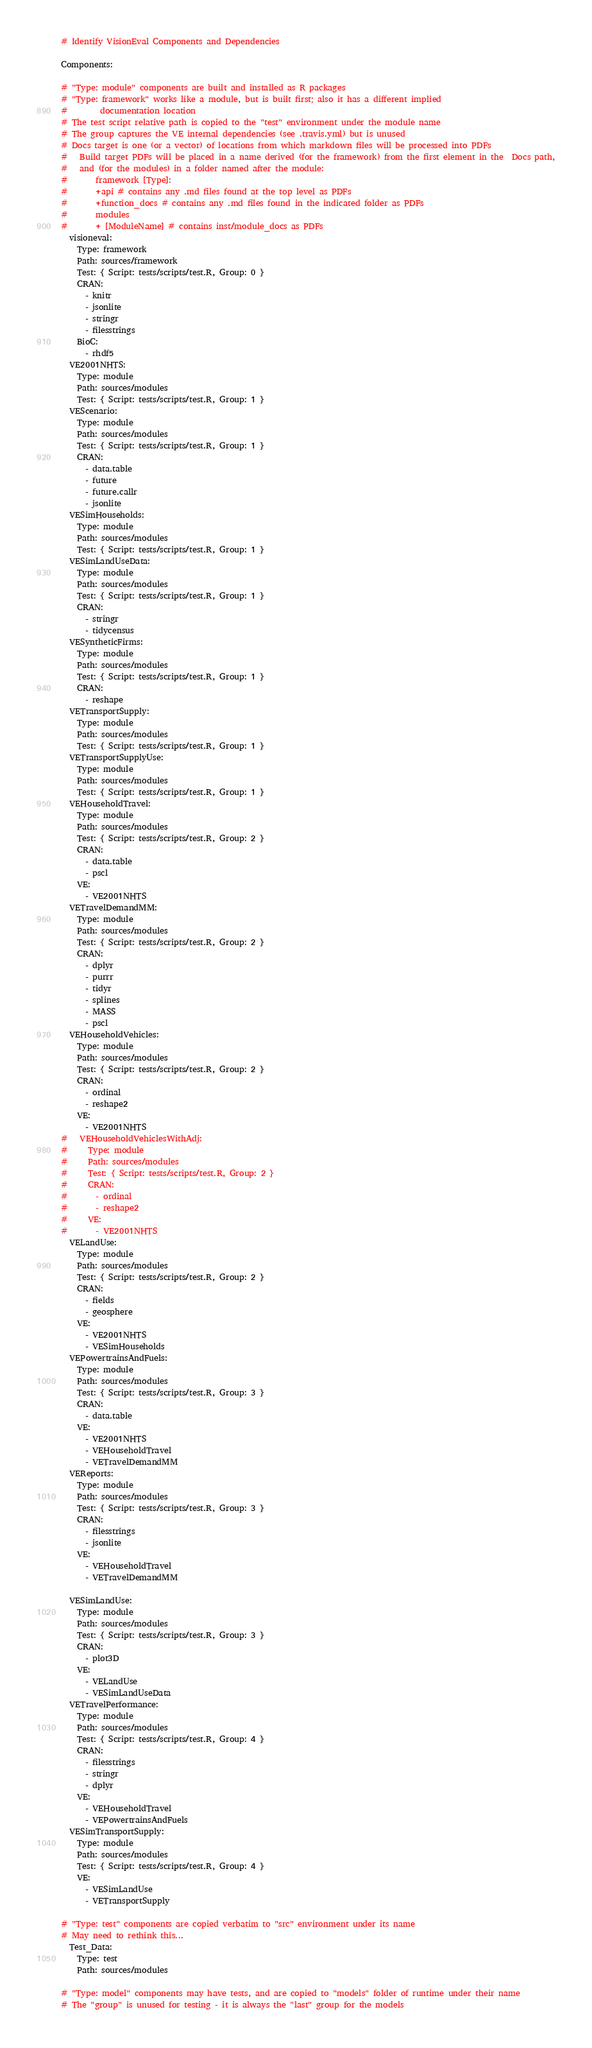<code> <loc_0><loc_0><loc_500><loc_500><_YAML_># Identify VisionEval Components and Dependencies

Components:

# "Type: module" components are built and installed as R packages
# "Type: framework" works like a module, but is built first; also it has a different implied
#        documentation location
# The test script relative path is copied to the "test" environment under the module name
# The group captures the VE internal dependencies (see .travis.yml) but is unused
# Docs target is one (or a vector) of locations from which markdown files will be processed into PDFs
#   Build target PDFs will be placed in a name derived (for the framework) from the first element in the  Docs path,
#   and (for the modules) in a folder named after the module:
#       framework [Type]:
#       +api # contains any .md files found at the top level as PDFs
#       +function_docs # contains any .md files found in the indicated folder as PDFs
#       modules
#       + [ModuleName] # contains inst/module_docs as PDFs
  visioneval:
    Type: framework
    Path: sources/framework
    Test: { Script: tests/scripts/test.R, Group: 0 }
    CRAN: 
      - knitr
      - jsonlite
      - stringr
      - filesstrings
    BioC:
      - rhdf5
  VE2001NHTS:
    Type: module
    Path: sources/modules
    Test: { Script: tests/scripts/test.R, Group: 1 }
  VEScenario:
    Type: module
    Path: sources/modules
    Test: { Script: tests/scripts/test.R, Group: 1 }
    CRAN:
      - data.table
      - future
      - future.callr
      - jsonlite
  VESimHouseholds:
    Type: module
    Path: sources/modules
    Test: { Script: tests/scripts/test.R, Group: 1 }
  VESimLandUseData:
    Type: module
    Path: sources/modules
    Test: { Script: tests/scripts/test.R, Group: 1 }
    CRAN:
      - stringr
      - tidycensus
  VESyntheticFirms:
    Type: module
    Path: sources/modules
    Test: { Script: tests/scripts/test.R, Group: 1 }
    CRAN:
      - reshape
  VETransportSupply:
    Type: module
    Path: sources/modules
    Test: { Script: tests/scripts/test.R, Group: 1 }
  VETransportSupplyUse:
    Type: module
    Path: sources/modules
    Test: { Script: tests/scripts/test.R, Group: 1 }
  VEHouseholdTravel:
    Type: module
    Path: sources/modules
    Test: { Script: tests/scripts/test.R, Group: 2 }
    CRAN:
      - data.table
      - pscl
    VE:
      - VE2001NHTS
  VETravelDemandMM:
    Type: module
    Path: sources/modules
    Test: { Script: tests/scripts/test.R, Group: 2 }
    CRAN:
      - dplyr
      - purrr
      - tidyr
      - splines
      - MASS 
      - pscl
  VEHouseholdVehicles:
    Type: module
    Path: sources/modules
    Test: { Script: tests/scripts/test.R, Group: 2 }
    CRAN:
      - ordinal
      - reshape2
    VE:
      - VE2001NHTS
#   VEHouseholdVehiclesWithAdj:
#     Type: module
#     Path: sources/modules
#     Test: { Script: tests/scripts/test.R, Group: 2 }
#     CRAN:
#       - ordinal
#       - reshape2
#     VE:
#       - VE2001NHTS
  VELandUse:
    Type: module
    Path: sources/modules
    Test: { Script: tests/scripts/test.R, Group: 2 }
    CRAN:
      - fields
      - geosphere
    VE:
      - VE2001NHTS
      - VESimHouseholds
  VEPowertrainsAndFuels:
    Type: module
    Path: sources/modules
    Test: { Script: tests/scripts/test.R, Group: 3 }
    CRAN:
      - data.table
    VE:
      - VE2001NHTS
      - VEHouseholdTravel
      - VETravelDemandMM      
  VEReports:
    Type: module
    Path: sources/modules
    Test: { Script: tests/scripts/test.R, Group: 3 }
    CRAN:
      - filesstrings
      - jsonlite
    VE:
      - VEHouseholdTravel
      - VETravelDemandMM

  VESimLandUse:
    Type: module
    Path: sources/modules
    Test: { Script: tests/scripts/test.R, Group: 3 }
    CRAN:
      - plot3D
    VE:
      - VELandUse
      - VESimLandUseData
  VETravelPerformance:
    Type: module
    Path: sources/modules
    Test: { Script: tests/scripts/test.R, Group: 4 }
    CRAN:
      - filesstrings
      - stringr
      - dplyr
    VE:
      - VEHouseholdTravel
      - VEPowertrainsAndFuels
  VESimTransportSupply:
    Type: module
    Path: sources/modules
    Test: { Script: tests/scripts/test.R, Group: 4 }
    VE:
      - VESimLandUse
      - VETransportSupply

# "Type: test" components are copied verbatim to "src" environment under its name
# May need to rethink this...
  Test_Data:
    Type: test
    Path: sources/modules

# "Type: model" components may have tests, and are copied to "models" folder of runtime under their name
# The "group" is unused for testing - it is always the "last" group for the models</code> 